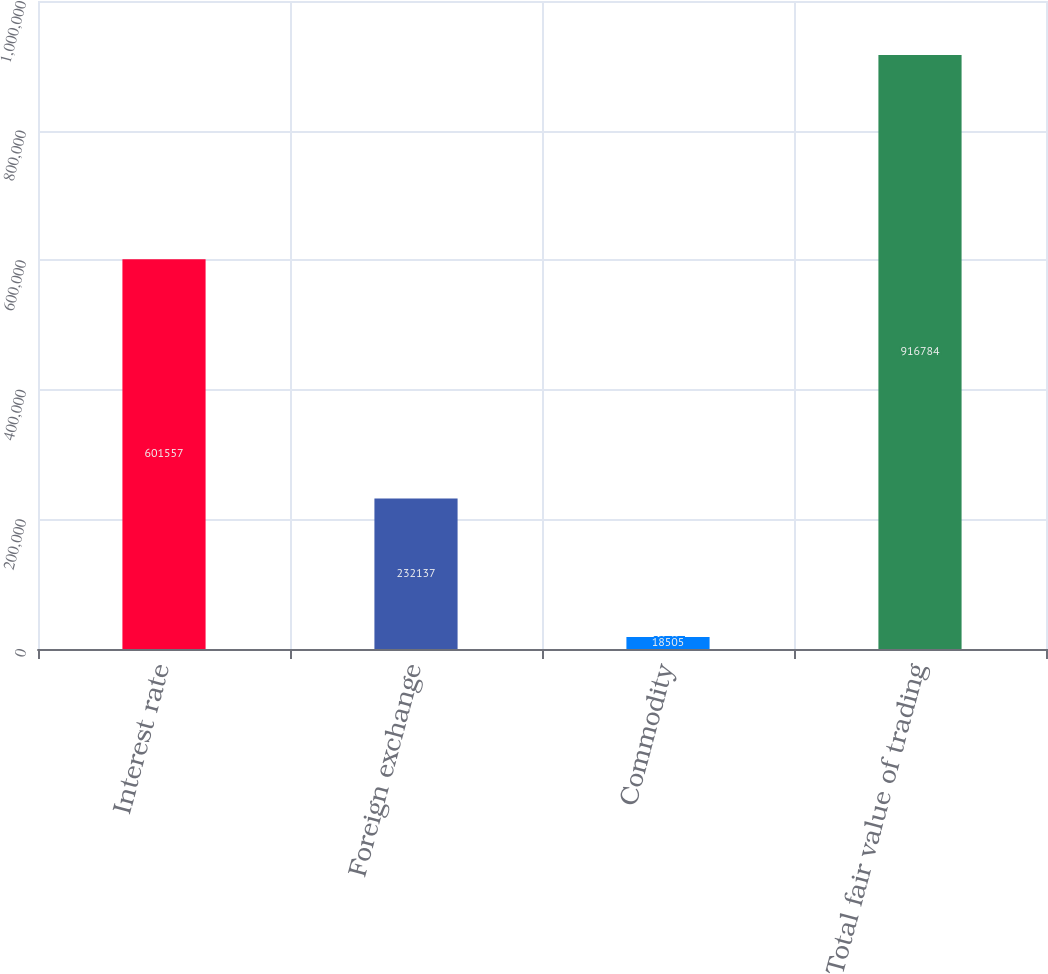<chart> <loc_0><loc_0><loc_500><loc_500><bar_chart><fcel>Interest rate<fcel>Foreign exchange<fcel>Commodity<fcel>Total fair value of trading<nl><fcel>601557<fcel>232137<fcel>18505<fcel>916784<nl></chart> 